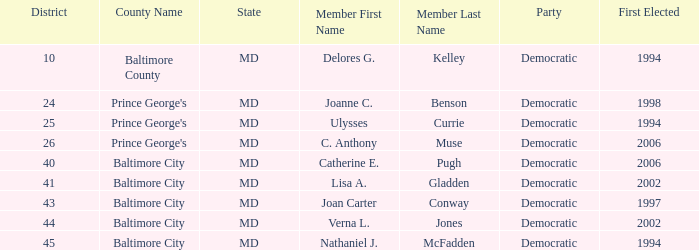Who was firest elected in 2002 in a district larger than 41? Verna L. Jones. 